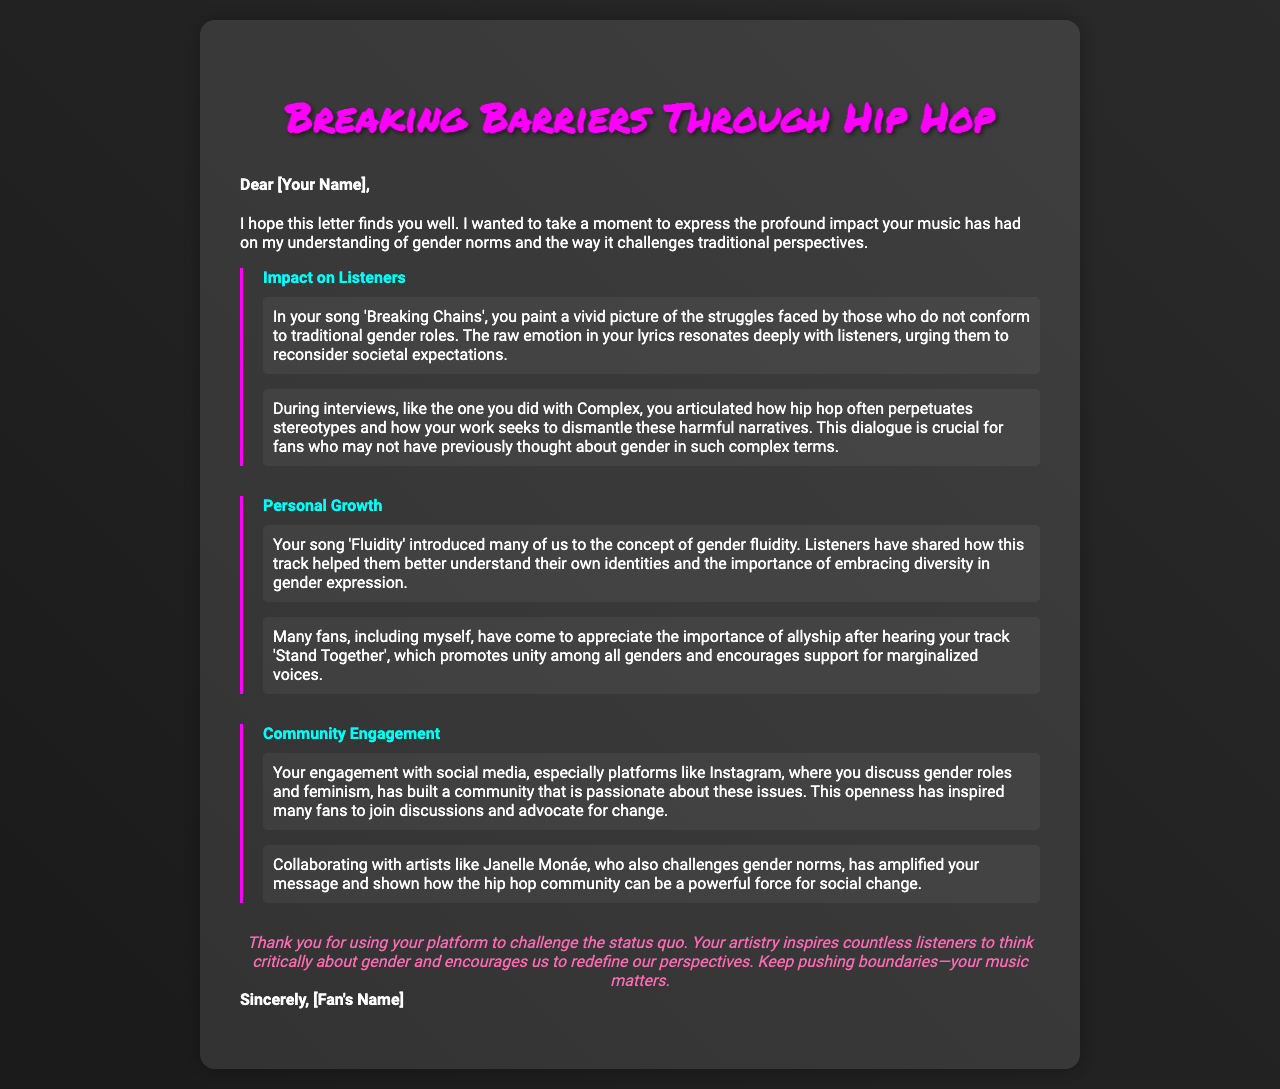what is the title of the letter? The title of the letter is prominently displayed at the top, capturing the main theme addressed in the document.
Answer: Breaking Barriers Through Hip Hop who is the letter addressed to? The greeting of the letter specifies the recipient to whom the letter is directed.
Answer: [Your Name] what song discusses struggles with traditional gender roles? An example from the letter highlights a specific song that addresses struggles related to gender norms.
Answer: Breaking Chains which song introduced listeners to the concept of gender fluidity? The document mentions a song that plays a significant role in educating listeners about gender fluidity.
Answer: Fluidity what social media platform is mentioned for community engagement? The letter references a specific platform where the artist engages with fans on gender roles and feminism.
Answer: Instagram who is mentioned as a collaborating artist that challenges gender norms? The document highlights a collaboration with another artist known for addressing similar themes.
Answer: Janelle Monáe which track promotes unity among all genders? The letter cites a track that encourages inclusivity and support for diverse gender identities.
Answer: Stand Together what is the concluding sentiment of the letter? The closing part of the letter reflects the writer's feelings about the artist's impact and contribution to challenging societal norms.
Answer: Your music matters 